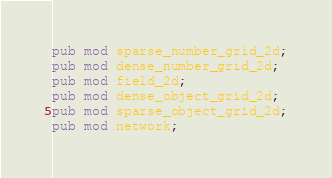Convert code to text. <code><loc_0><loc_0><loc_500><loc_500><_Rust_>pub mod sparse_number_grid_2d;
pub mod dense_number_grid_2d;
pub mod field_2d;
pub mod dense_object_grid_2d;
pub mod sparse_object_grid_2d;
pub mod network;
</code> 